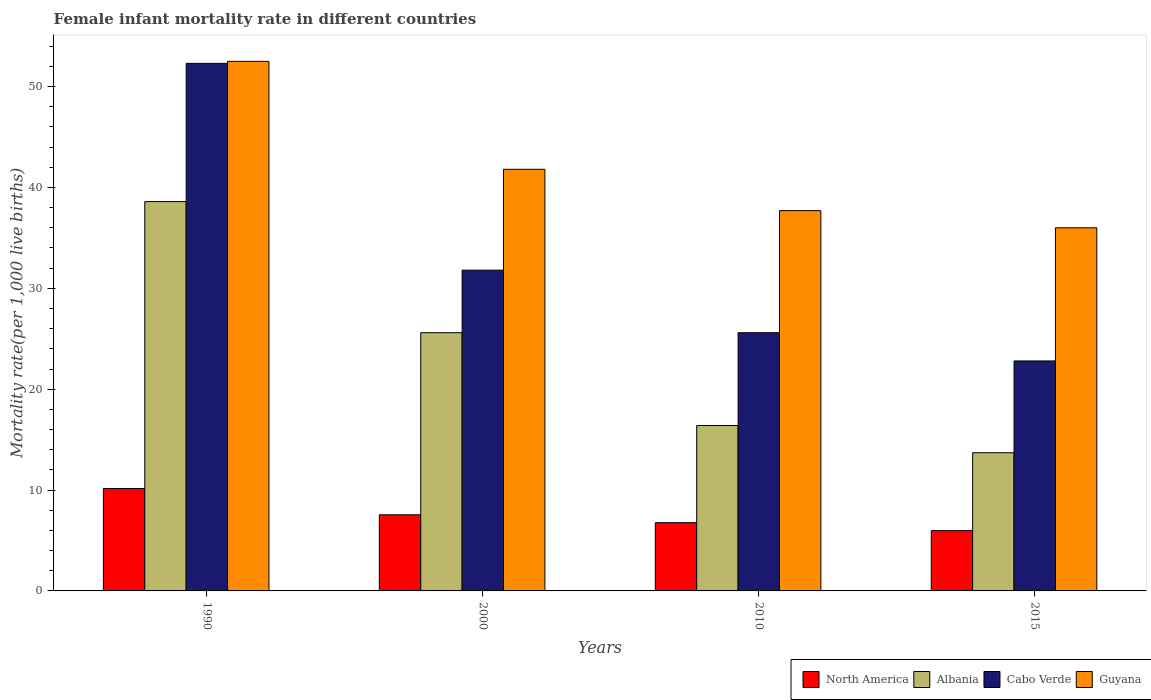How many groups of bars are there?
Give a very brief answer. 4. How many bars are there on the 1st tick from the left?
Your answer should be compact. 4. In how many cases, is the number of bars for a given year not equal to the number of legend labels?
Ensure brevity in your answer.  0. What is the female infant mortality rate in Albania in 2010?
Make the answer very short. 16.4. Across all years, what is the maximum female infant mortality rate in Guyana?
Your response must be concise. 52.5. Across all years, what is the minimum female infant mortality rate in North America?
Ensure brevity in your answer.  5.98. In which year was the female infant mortality rate in Cabo Verde minimum?
Offer a terse response. 2015. What is the total female infant mortality rate in North America in the graph?
Your response must be concise. 30.44. What is the difference between the female infant mortality rate in Guyana in 2000 and the female infant mortality rate in Cabo Verde in 2015?
Offer a terse response. 19. In the year 2015, what is the difference between the female infant mortality rate in North America and female infant mortality rate in Albania?
Your answer should be very brief. -7.72. In how many years, is the female infant mortality rate in Cabo Verde greater than 46?
Ensure brevity in your answer.  1. What is the ratio of the female infant mortality rate in Guyana in 2000 to that in 2010?
Your answer should be compact. 1.11. Is the female infant mortality rate in Albania in 2000 less than that in 2010?
Provide a succinct answer. No. What is the difference between the highest and the second highest female infant mortality rate in Albania?
Keep it short and to the point. 13. In how many years, is the female infant mortality rate in Guyana greater than the average female infant mortality rate in Guyana taken over all years?
Offer a terse response. 1. Is the sum of the female infant mortality rate in Guyana in 2010 and 2015 greater than the maximum female infant mortality rate in Albania across all years?
Your answer should be very brief. Yes. What does the 1st bar from the left in 1990 represents?
Your answer should be very brief. North America. What does the 3rd bar from the right in 2015 represents?
Provide a succinct answer. Albania. Is it the case that in every year, the sum of the female infant mortality rate in Guyana and female infant mortality rate in North America is greater than the female infant mortality rate in Albania?
Provide a succinct answer. Yes. How many years are there in the graph?
Your response must be concise. 4. What is the difference between two consecutive major ticks on the Y-axis?
Give a very brief answer. 10. Are the values on the major ticks of Y-axis written in scientific E-notation?
Offer a very short reply. No. Does the graph contain any zero values?
Your response must be concise. No. Does the graph contain grids?
Provide a succinct answer. No. Where does the legend appear in the graph?
Keep it short and to the point. Bottom right. How are the legend labels stacked?
Provide a succinct answer. Horizontal. What is the title of the graph?
Make the answer very short. Female infant mortality rate in different countries. What is the label or title of the Y-axis?
Keep it short and to the point. Mortality rate(per 1,0 live births). What is the Mortality rate(per 1,000 live births) of North America in 1990?
Your response must be concise. 10.15. What is the Mortality rate(per 1,000 live births) in Albania in 1990?
Give a very brief answer. 38.6. What is the Mortality rate(per 1,000 live births) in Cabo Verde in 1990?
Ensure brevity in your answer.  52.3. What is the Mortality rate(per 1,000 live births) of Guyana in 1990?
Ensure brevity in your answer.  52.5. What is the Mortality rate(per 1,000 live births) in North America in 2000?
Keep it short and to the point. 7.55. What is the Mortality rate(per 1,000 live births) in Albania in 2000?
Your answer should be very brief. 25.6. What is the Mortality rate(per 1,000 live births) of Cabo Verde in 2000?
Keep it short and to the point. 31.8. What is the Mortality rate(per 1,000 live births) of Guyana in 2000?
Make the answer very short. 41.8. What is the Mortality rate(per 1,000 live births) of North America in 2010?
Provide a short and direct response. 6.76. What is the Mortality rate(per 1,000 live births) in Cabo Verde in 2010?
Provide a short and direct response. 25.6. What is the Mortality rate(per 1,000 live births) in Guyana in 2010?
Offer a terse response. 37.7. What is the Mortality rate(per 1,000 live births) in North America in 2015?
Offer a very short reply. 5.98. What is the Mortality rate(per 1,000 live births) in Cabo Verde in 2015?
Your answer should be compact. 22.8. Across all years, what is the maximum Mortality rate(per 1,000 live births) in North America?
Provide a succinct answer. 10.15. Across all years, what is the maximum Mortality rate(per 1,000 live births) of Albania?
Provide a short and direct response. 38.6. Across all years, what is the maximum Mortality rate(per 1,000 live births) of Cabo Verde?
Make the answer very short. 52.3. Across all years, what is the maximum Mortality rate(per 1,000 live births) in Guyana?
Your answer should be compact. 52.5. Across all years, what is the minimum Mortality rate(per 1,000 live births) in North America?
Offer a terse response. 5.98. Across all years, what is the minimum Mortality rate(per 1,000 live births) of Albania?
Your answer should be compact. 13.7. Across all years, what is the minimum Mortality rate(per 1,000 live births) of Cabo Verde?
Ensure brevity in your answer.  22.8. What is the total Mortality rate(per 1,000 live births) in North America in the graph?
Your answer should be very brief. 30.44. What is the total Mortality rate(per 1,000 live births) of Albania in the graph?
Provide a succinct answer. 94.3. What is the total Mortality rate(per 1,000 live births) in Cabo Verde in the graph?
Your response must be concise. 132.5. What is the total Mortality rate(per 1,000 live births) in Guyana in the graph?
Offer a very short reply. 168. What is the difference between the Mortality rate(per 1,000 live births) of North America in 1990 and that in 2000?
Your answer should be very brief. 2.61. What is the difference between the Mortality rate(per 1,000 live births) in Albania in 1990 and that in 2000?
Provide a short and direct response. 13. What is the difference between the Mortality rate(per 1,000 live births) in Cabo Verde in 1990 and that in 2000?
Give a very brief answer. 20.5. What is the difference between the Mortality rate(per 1,000 live births) of Guyana in 1990 and that in 2000?
Give a very brief answer. 10.7. What is the difference between the Mortality rate(per 1,000 live births) in North America in 1990 and that in 2010?
Offer a very short reply. 3.39. What is the difference between the Mortality rate(per 1,000 live births) in Cabo Verde in 1990 and that in 2010?
Offer a very short reply. 26.7. What is the difference between the Mortality rate(per 1,000 live births) of North America in 1990 and that in 2015?
Your answer should be compact. 4.17. What is the difference between the Mortality rate(per 1,000 live births) of Albania in 1990 and that in 2015?
Provide a short and direct response. 24.9. What is the difference between the Mortality rate(per 1,000 live births) of Cabo Verde in 1990 and that in 2015?
Provide a short and direct response. 29.5. What is the difference between the Mortality rate(per 1,000 live births) of North America in 2000 and that in 2010?
Your answer should be compact. 0.78. What is the difference between the Mortality rate(per 1,000 live births) of Albania in 2000 and that in 2010?
Your response must be concise. 9.2. What is the difference between the Mortality rate(per 1,000 live births) in Cabo Verde in 2000 and that in 2010?
Make the answer very short. 6.2. What is the difference between the Mortality rate(per 1,000 live births) in Guyana in 2000 and that in 2010?
Give a very brief answer. 4.1. What is the difference between the Mortality rate(per 1,000 live births) of North America in 2000 and that in 2015?
Provide a short and direct response. 1.57. What is the difference between the Mortality rate(per 1,000 live births) in Albania in 2000 and that in 2015?
Give a very brief answer. 11.9. What is the difference between the Mortality rate(per 1,000 live births) of Cabo Verde in 2000 and that in 2015?
Make the answer very short. 9. What is the difference between the Mortality rate(per 1,000 live births) in Guyana in 2000 and that in 2015?
Ensure brevity in your answer.  5.8. What is the difference between the Mortality rate(per 1,000 live births) of North America in 2010 and that in 2015?
Give a very brief answer. 0.79. What is the difference between the Mortality rate(per 1,000 live births) of Guyana in 2010 and that in 2015?
Ensure brevity in your answer.  1.7. What is the difference between the Mortality rate(per 1,000 live births) in North America in 1990 and the Mortality rate(per 1,000 live births) in Albania in 2000?
Your response must be concise. -15.45. What is the difference between the Mortality rate(per 1,000 live births) in North America in 1990 and the Mortality rate(per 1,000 live births) in Cabo Verde in 2000?
Your response must be concise. -21.65. What is the difference between the Mortality rate(per 1,000 live births) in North America in 1990 and the Mortality rate(per 1,000 live births) in Guyana in 2000?
Ensure brevity in your answer.  -31.65. What is the difference between the Mortality rate(per 1,000 live births) of Albania in 1990 and the Mortality rate(per 1,000 live births) of Cabo Verde in 2000?
Make the answer very short. 6.8. What is the difference between the Mortality rate(per 1,000 live births) of Albania in 1990 and the Mortality rate(per 1,000 live births) of Guyana in 2000?
Your answer should be compact. -3.2. What is the difference between the Mortality rate(per 1,000 live births) in North America in 1990 and the Mortality rate(per 1,000 live births) in Albania in 2010?
Offer a terse response. -6.25. What is the difference between the Mortality rate(per 1,000 live births) of North America in 1990 and the Mortality rate(per 1,000 live births) of Cabo Verde in 2010?
Make the answer very short. -15.45. What is the difference between the Mortality rate(per 1,000 live births) of North America in 1990 and the Mortality rate(per 1,000 live births) of Guyana in 2010?
Your answer should be very brief. -27.55. What is the difference between the Mortality rate(per 1,000 live births) of Albania in 1990 and the Mortality rate(per 1,000 live births) of Cabo Verde in 2010?
Keep it short and to the point. 13. What is the difference between the Mortality rate(per 1,000 live births) of Cabo Verde in 1990 and the Mortality rate(per 1,000 live births) of Guyana in 2010?
Keep it short and to the point. 14.6. What is the difference between the Mortality rate(per 1,000 live births) in North America in 1990 and the Mortality rate(per 1,000 live births) in Albania in 2015?
Make the answer very short. -3.55. What is the difference between the Mortality rate(per 1,000 live births) of North America in 1990 and the Mortality rate(per 1,000 live births) of Cabo Verde in 2015?
Provide a short and direct response. -12.65. What is the difference between the Mortality rate(per 1,000 live births) of North America in 1990 and the Mortality rate(per 1,000 live births) of Guyana in 2015?
Your response must be concise. -25.85. What is the difference between the Mortality rate(per 1,000 live births) in Cabo Verde in 1990 and the Mortality rate(per 1,000 live births) in Guyana in 2015?
Your answer should be very brief. 16.3. What is the difference between the Mortality rate(per 1,000 live births) of North America in 2000 and the Mortality rate(per 1,000 live births) of Albania in 2010?
Provide a succinct answer. -8.85. What is the difference between the Mortality rate(per 1,000 live births) of North America in 2000 and the Mortality rate(per 1,000 live births) of Cabo Verde in 2010?
Give a very brief answer. -18.05. What is the difference between the Mortality rate(per 1,000 live births) of North America in 2000 and the Mortality rate(per 1,000 live births) of Guyana in 2010?
Make the answer very short. -30.15. What is the difference between the Mortality rate(per 1,000 live births) of Albania in 2000 and the Mortality rate(per 1,000 live births) of Guyana in 2010?
Offer a very short reply. -12.1. What is the difference between the Mortality rate(per 1,000 live births) of Cabo Verde in 2000 and the Mortality rate(per 1,000 live births) of Guyana in 2010?
Your answer should be very brief. -5.9. What is the difference between the Mortality rate(per 1,000 live births) in North America in 2000 and the Mortality rate(per 1,000 live births) in Albania in 2015?
Give a very brief answer. -6.15. What is the difference between the Mortality rate(per 1,000 live births) of North America in 2000 and the Mortality rate(per 1,000 live births) of Cabo Verde in 2015?
Your answer should be compact. -15.25. What is the difference between the Mortality rate(per 1,000 live births) in North America in 2000 and the Mortality rate(per 1,000 live births) in Guyana in 2015?
Your response must be concise. -28.45. What is the difference between the Mortality rate(per 1,000 live births) in Albania in 2000 and the Mortality rate(per 1,000 live births) in Guyana in 2015?
Ensure brevity in your answer.  -10.4. What is the difference between the Mortality rate(per 1,000 live births) in North America in 2010 and the Mortality rate(per 1,000 live births) in Albania in 2015?
Your answer should be very brief. -6.94. What is the difference between the Mortality rate(per 1,000 live births) of North America in 2010 and the Mortality rate(per 1,000 live births) of Cabo Verde in 2015?
Your answer should be very brief. -16.04. What is the difference between the Mortality rate(per 1,000 live births) of North America in 2010 and the Mortality rate(per 1,000 live births) of Guyana in 2015?
Provide a succinct answer. -29.24. What is the difference between the Mortality rate(per 1,000 live births) in Albania in 2010 and the Mortality rate(per 1,000 live births) in Guyana in 2015?
Make the answer very short. -19.6. What is the average Mortality rate(per 1,000 live births) of North America per year?
Your response must be concise. 7.61. What is the average Mortality rate(per 1,000 live births) of Albania per year?
Keep it short and to the point. 23.57. What is the average Mortality rate(per 1,000 live births) in Cabo Verde per year?
Offer a very short reply. 33.12. What is the average Mortality rate(per 1,000 live births) in Guyana per year?
Provide a short and direct response. 42. In the year 1990, what is the difference between the Mortality rate(per 1,000 live births) in North America and Mortality rate(per 1,000 live births) in Albania?
Offer a very short reply. -28.45. In the year 1990, what is the difference between the Mortality rate(per 1,000 live births) in North America and Mortality rate(per 1,000 live births) in Cabo Verde?
Give a very brief answer. -42.15. In the year 1990, what is the difference between the Mortality rate(per 1,000 live births) in North America and Mortality rate(per 1,000 live births) in Guyana?
Your answer should be compact. -42.35. In the year 1990, what is the difference between the Mortality rate(per 1,000 live births) of Albania and Mortality rate(per 1,000 live births) of Cabo Verde?
Offer a terse response. -13.7. In the year 1990, what is the difference between the Mortality rate(per 1,000 live births) of Cabo Verde and Mortality rate(per 1,000 live births) of Guyana?
Your response must be concise. -0.2. In the year 2000, what is the difference between the Mortality rate(per 1,000 live births) in North America and Mortality rate(per 1,000 live births) in Albania?
Your answer should be very brief. -18.05. In the year 2000, what is the difference between the Mortality rate(per 1,000 live births) of North America and Mortality rate(per 1,000 live births) of Cabo Verde?
Your answer should be compact. -24.25. In the year 2000, what is the difference between the Mortality rate(per 1,000 live births) in North America and Mortality rate(per 1,000 live births) in Guyana?
Keep it short and to the point. -34.25. In the year 2000, what is the difference between the Mortality rate(per 1,000 live births) of Albania and Mortality rate(per 1,000 live births) of Guyana?
Keep it short and to the point. -16.2. In the year 2000, what is the difference between the Mortality rate(per 1,000 live births) in Cabo Verde and Mortality rate(per 1,000 live births) in Guyana?
Make the answer very short. -10. In the year 2010, what is the difference between the Mortality rate(per 1,000 live births) in North America and Mortality rate(per 1,000 live births) in Albania?
Provide a short and direct response. -9.64. In the year 2010, what is the difference between the Mortality rate(per 1,000 live births) in North America and Mortality rate(per 1,000 live births) in Cabo Verde?
Your answer should be very brief. -18.84. In the year 2010, what is the difference between the Mortality rate(per 1,000 live births) of North America and Mortality rate(per 1,000 live births) of Guyana?
Ensure brevity in your answer.  -30.94. In the year 2010, what is the difference between the Mortality rate(per 1,000 live births) of Albania and Mortality rate(per 1,000 live births) of Cabo Verde?
Offer a terse response. -9.2. In the year 2010, what is the difference between the Mortality rate(per 1,000 live births) of Albania and Mortality rate(per 1,000 live births) of Guyana?
Make the answer very short. -21.3. In the year 2015, what is the difference between the Mortality rate(per 1,000 live births) of North America and Mortality rate(per 1,000 live births) of Albania?
Your answer should be very brief. -7.72. In the year 2015, what is the difference between the Mortality rate(per 1,000 live births) of North America and Mortality rate(per 1,000 live births) of Cabo Verde?
Ensure brevity in your answer.  -16.82. In the year 2015, what is the difference between the Mortality rate(per 1,000 live births) in North America and Mortality rate(per 1,000 live births) in Guyana?
Offer a terse response. -30.02. In the year 2015, what is the difference between the Mortality rate(per 1,000 live births) of Albania and Mortality rate(per 1,000 live births) of Guyana?
Offer a terse response. -22.3. In the year 2015, what is the difference between the Mortality rate(per 1,000 live births) of Cabo Verde and Mortality rate(per 1,000 live births) of Guyana?
Make the answer very short. -13.2. What is the ratio of the Mortality rate(per 1,000 live births) in North America in 1990 to that in 2000?
Give a very brief answer. 1.35. What is the ratio of the Mortality rate(per 1,000 live births) in Albania in 1990 to that in 2000?
Make the answer very short. 1.51. What is the ratio of the Mortality rate(per 1,000 live births) of Cabo Verde in 1990 to that in 2000?
Ensure brevity in your answer.  1.64. What is the ratio of the Mortality rate(per 1,000 live births) of Guyana in 1990 to that in 2000?
Offer a very short reply. 1.26. What is the ratio of the Mortality rate(per 1,000 live births) of North America in 1990 to that in 2010?
Keep it short and to the point. 1.5. What is the ratio of the Mortality rate(per 1,000 live births) in Albania in 1990 to that in 2010?
Offer a terse response. 2.35. What is the ratio of the Mortality rate(per 1,000 live births) of Cabo Verde in 1990 to that in 2010?
Offer a very short reply. 2.04. What is the ratio of the Mortality rate(per 1,000 live births) in Guyana in 1990 to that in 2010?
Your answer should be compact. 1.39. What is the ratio of the Mortality rate(per 1,000 live births) of North America in 1990 to that in 2015?
Offer a terse response. 1.7. What is the ratio of the Mortality rate(per 1,000 live births) of Albania in 1990 to that in 2015?
Keep it short and to the point. 2.82. What is the ratio of the Mortality rate(per 1,000 live births) of Cabo Verde in 1990 to that in 2015?
Ensure brevity in your answer.  2.29. What is the ratio of the Mortality rate(per 1,000 live births) in Guyana in 1990 to that in 2015?
Give a very brief answer. 1.46. What is the ratio of the Mortality rate(per 1,000 live births) in North America in 2000 to that in 2010?
Ensure brevity in your answer.  1.12. What is the ratio of the Mortality rate(per 1,000 live births) of Albania in 2000 to that in 2010?
Give a very brief answer. 1.56. What is the ratio of the Mortality rate(per 1,000 live births) of Cabo Verde in 2000 to that in 2010?
Offer a very short reply. 1.24. What is the ratio of the Mortality rate(per 1,000 live births) in Guyana in 2000 to that in 2010?
Offer a terse response. 1.11. What is the ratio of the Mortality rate(per 1,000 live births) in North America in 2000 to that in 2015?
Your answer should be very brief. 1.26. What is the ratio of the Mortality rate(per 1,000 live births) of Albania in 2000 to that in 2015?
Provide a short and direct response. 1.87. What is the ratio of the Mortality rate(per 1,000 live births) of Cabo Verde in 2000 to that in 2015?
Your answer should be very brief. 1.39. What is the ratio of the Mortality rate(per 1,000 live births) in Guyana in 2000 to that in 2015?
Provide a short and direct response. 1.16. What is the ratio of the Mortality rate(per 1,000 live births) of North America in 2010 to that in 2015?
Provide a short and direct response. 1.13. What is the ratio of the Mortality rate(per 1,000 live births) in Albania in 2010 to that in 2015?
Provide a short and direct response. 1.2. What is the ratio of the Mortality rate(per 1,000 live births) of Cabo Verde in 2010 to that in 2015?
Offer a terse response. 1.12. What is the ratio of the Mortality rate(per 1,000 live births) in Guyana in 2010 to that in 2015?
Your answer should be compact. 1.05. What is the difference between the highest and the second highest Mortality rate(per 1,000 live births) in North America?
Offer a very short reply. 2.61. What is the difference between the highest and the second highest Mortality rate(per 1,000 live births) in Cabo Verde?
Your response must be concise. 20.5. What is the difference between the highest and the lowest Mortality rate(per 1,000 live births) in North America?
Make the answer very short. 4.17. What is the difference between the highest and the lowest Mortality rate(per 1,000 live births) in Albania?
Make the answer very short. 24.9. What is the difference between the highest and the lowest Mortality rate(per 1,000 live births) of Cabo Verde?
Offer a terse response. 29.5. 